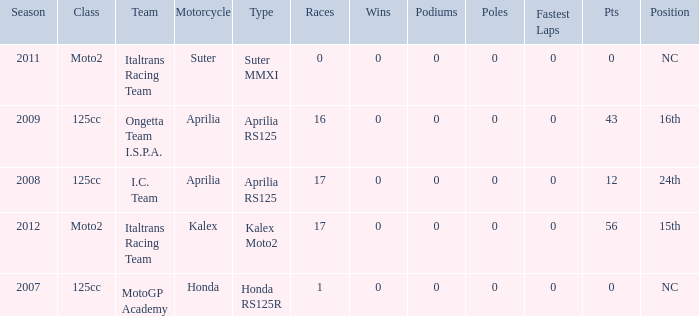What's Italtrans Racing Team's, with 0 pts, class? Moto2. 